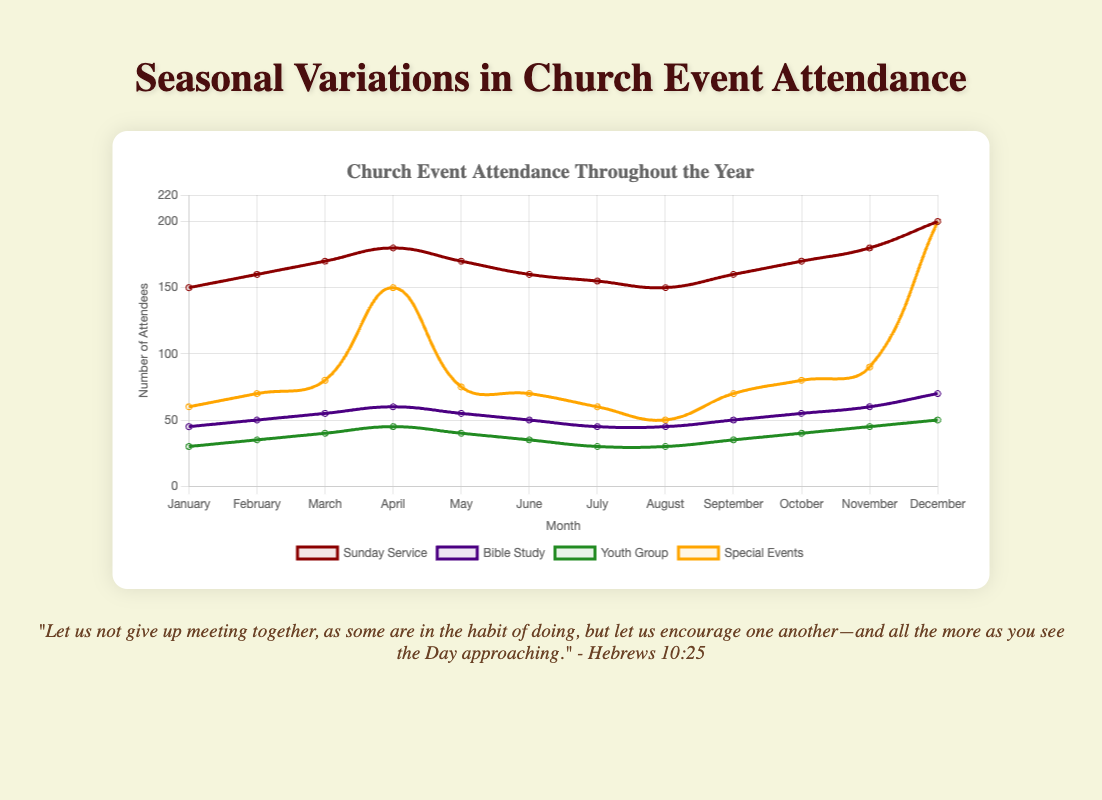Which month has the highest Sunday service attendance? The highest peak in the red line represents the month with the highest Sunday service attendance. The peak occurs in December.
Answer: December By how much does the special event attendance increase from November to December? Look at the orange line for the values in November and December. The values are 90 and 200, respectively. The difference is 200 - 90 = 110.
Answer: 110 What is the average attendance for Bible study in the first quarter (January to March)? Add the values for January, February, and March: 45 + 50 + 55 = 150. Then divide by 3. The average attendance is 150 / 3 = 50.
Answer: 50 During which month is the difference between Sunday service and youth group attendance the greatest? Calculate the difference for each month. For example, in December, the difference is 200 - 50 = 150. Compare all the differences and find the greatest one, which occurs in December.
Answer: December Which event shows the most significant variation in attendance throughout the year? Observe the changes in lines: the orange line (special event) has the most significant peaks and troughs, indicating substantial variation.
Answer: Special events What is the median monthly attendance for the Youth Group throughout the year? List the youth group attendance values in ascending order: [30, 30, 30, 30, 35, 35, 35, 40, 40, 40, 45, 50]. The median is the average of the 6th and 7th values (35+35)/2 = 35.
Answer: 35 Which month shows the largest drop in special event attendance compared to the previous month? Identify drops in the orange line. The most significant drop is from April (150) to May (75), which is a decrease of 75 attendees.
Answer: May How does the attendance for Bible study in June compare to that in October? Look at the purple line for June (50) and October (55). There is a decrease of 5 from October to June.
Answer: Decreased by 5 What is the total attendance for all events combined in December? Sum all values for December: 200 (Sunday service) + 70 (Bible study) + 50 (Youth group) + 200 (special events) = 520.
Answer: 520 How many times does the special event attendance peak above 100? Count instances where the orange line exceeds 100. This occurs twice: in April (150) and December (200).
Answer: Twice 